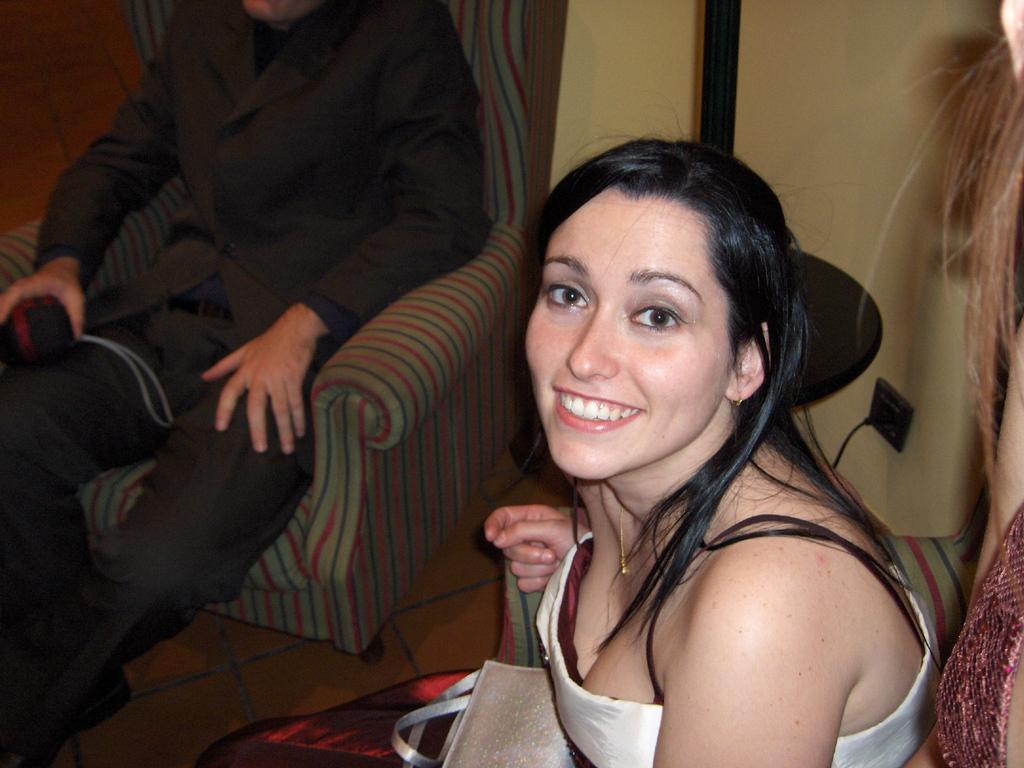How would you summarize this image in a sentence or two? In this image I can see two persons are sitting on sofa chairs. In the front I can see one of them is wearing white colour dress and in the background I can see another one is wearing black colour dress. In the front I can see a bag and in the background I can see one of them is holding an object. On the right side of this image I can see one more person. 